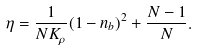<formula> <loc_0><loc_0><loc_500><loc_500>\eta = \frac { 1 } { N K _ { \rho } } ( 1 - n _ { b } ) ^ { 2 } + \frac { N - 1 } { N } .</formula> 